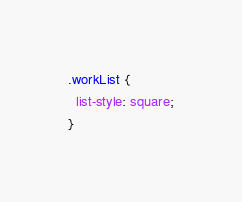<code> <loc_0><loc_0><loc_500><loc_500><_CSS_>.workList {
  list-style: square;
}
</code> 